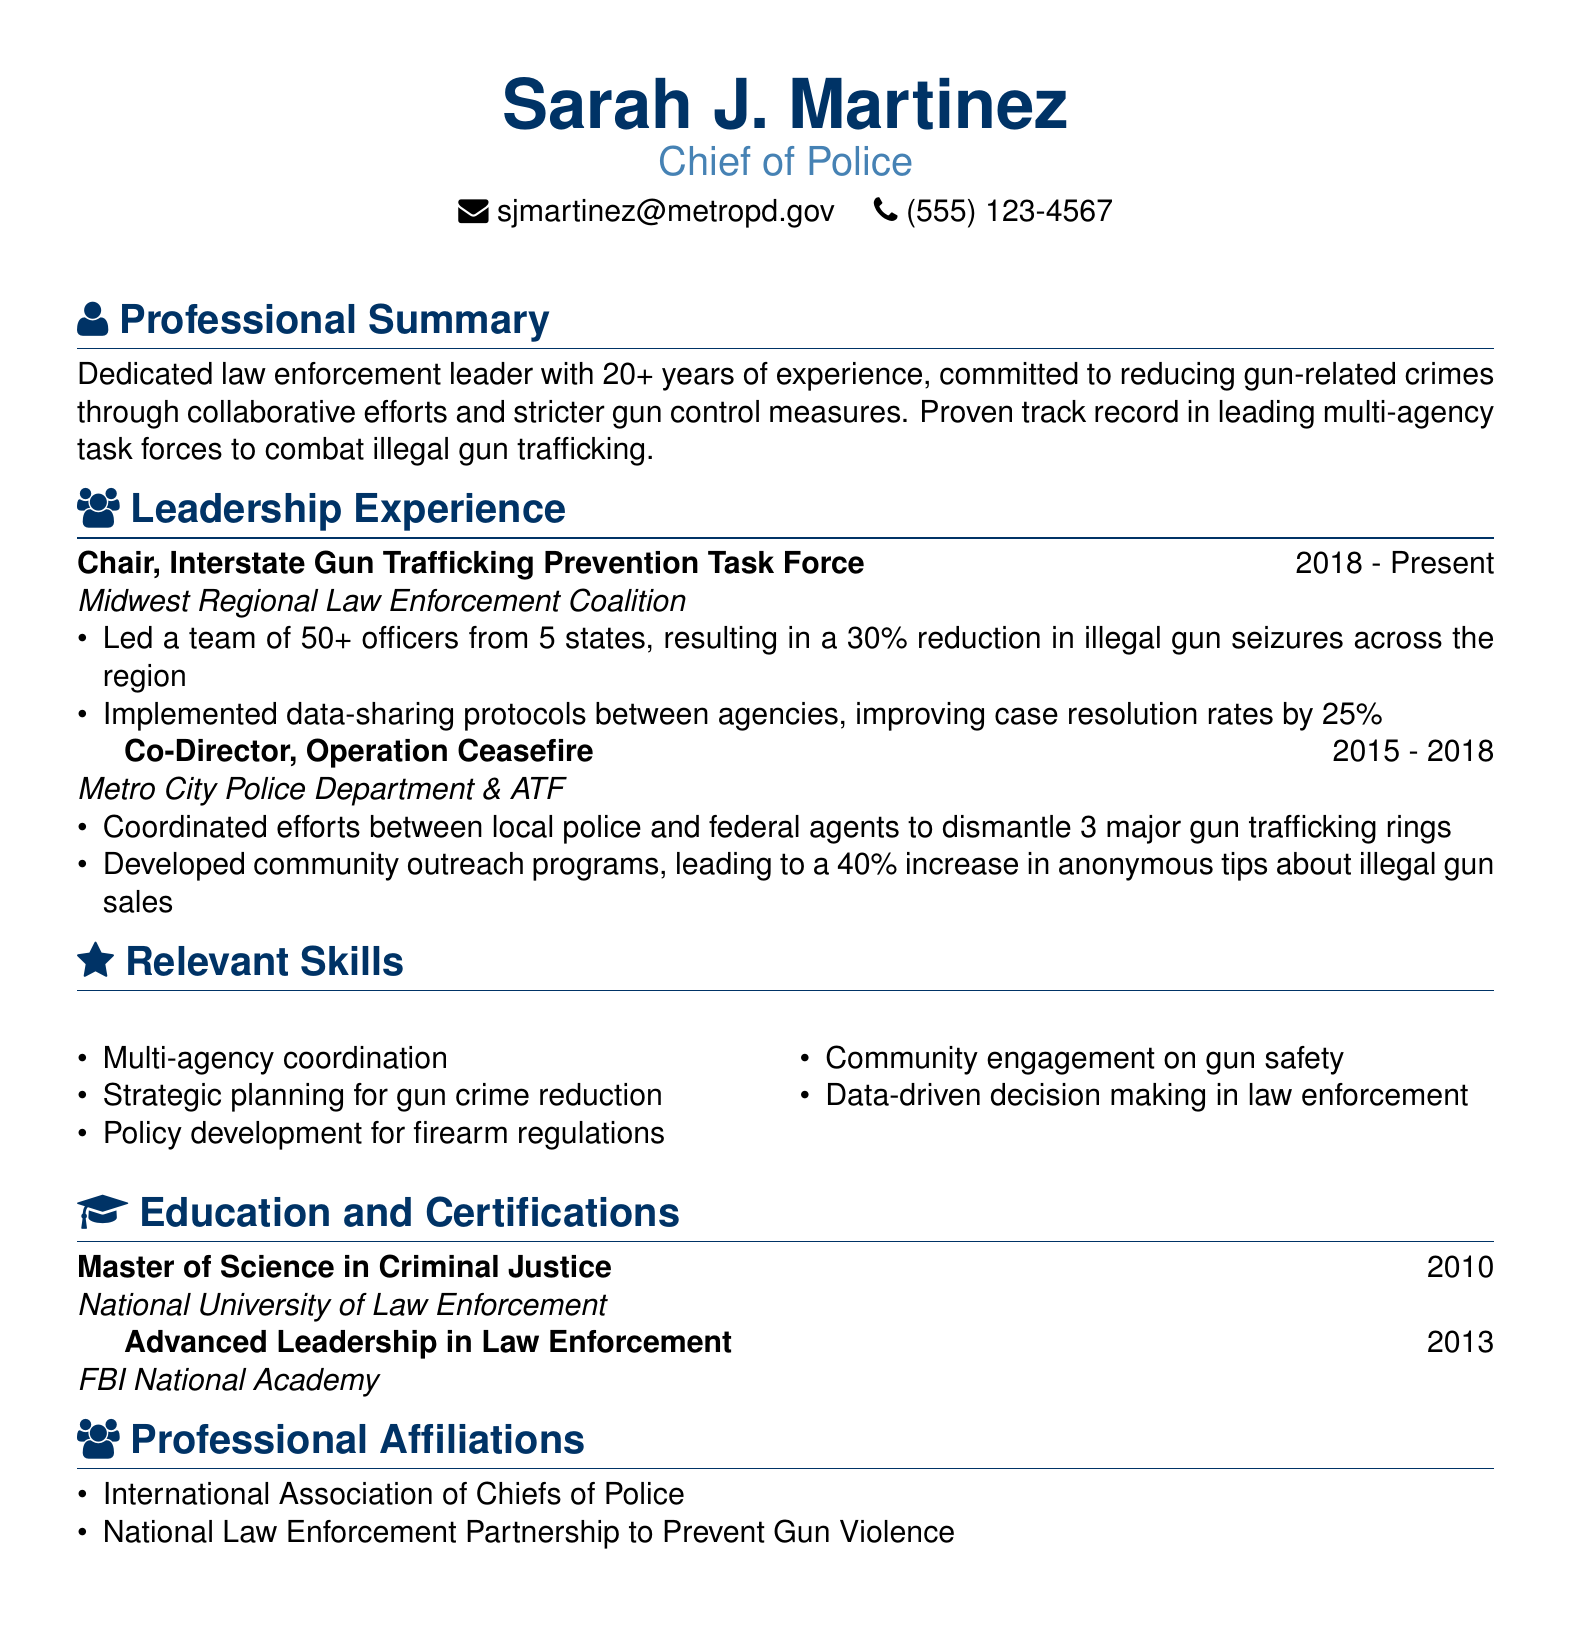what is the name of the chief of police? The chief of police's name is stated in the personal information section of the document.
Answer: Sarah J. Martinez how many years of experience does Sarah J. Martinez have? The professional summary mentions the years of experience of Sarah J. Martinez.
Answer: 20+ what title does Sarah J. Martinez hold in the Interstate Gun Trafficking Prevention Task Force? The leadership experience section lists the title held by Sarah J. Martinez in this task force.
Answer: Chair which agency collaborated with Metro City Police Department in Operation Ceasefire? The leadership experience section specifies the collaborating agency for Operation Ceasefire.
Answer: ATF what percentage reduction in illegal gun seizures was achieved under Sarah J. Martinez's leadership? The achievements in the leadership experience section provide the percentage reduction achieved.
Answer: 30% how many major gun trafficking rings were dismantled during Operation Ceasefire? The document states the number of major gun trafficking rings dismantled in the leadership experience section.
Answer: 3 what advanced certification did Sarah J. Martinez obtain in 2013? The education and certifications section lists the advanced certification received by Sarah J. Martinez.
Answer: Advanced Leadership in Law Enforcement which professional association is focused on preventing gun violence? The professional affiliations section mentions the association dedicated to preventing gun violence.
Answer: National Law Enforcement Partnership to Prevent Gun Violence 